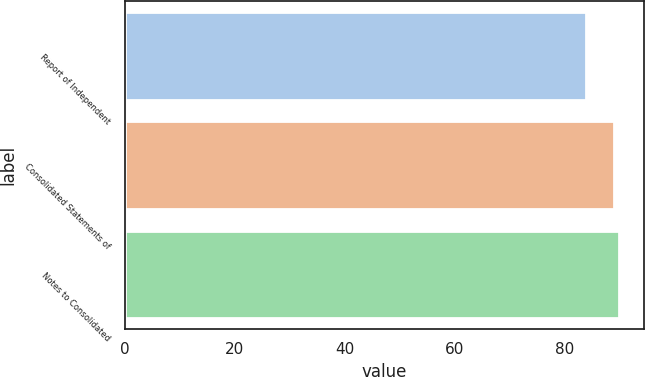<chart> <loc_0><loc_0><loc_500><loc_500><bar_chart><fcel>Report of Independent<fcel>Consolidated Statements of<fcel>Notes to Consolidated<nl><fcel>84<fcel>89<fcel>90<nl></chart> 